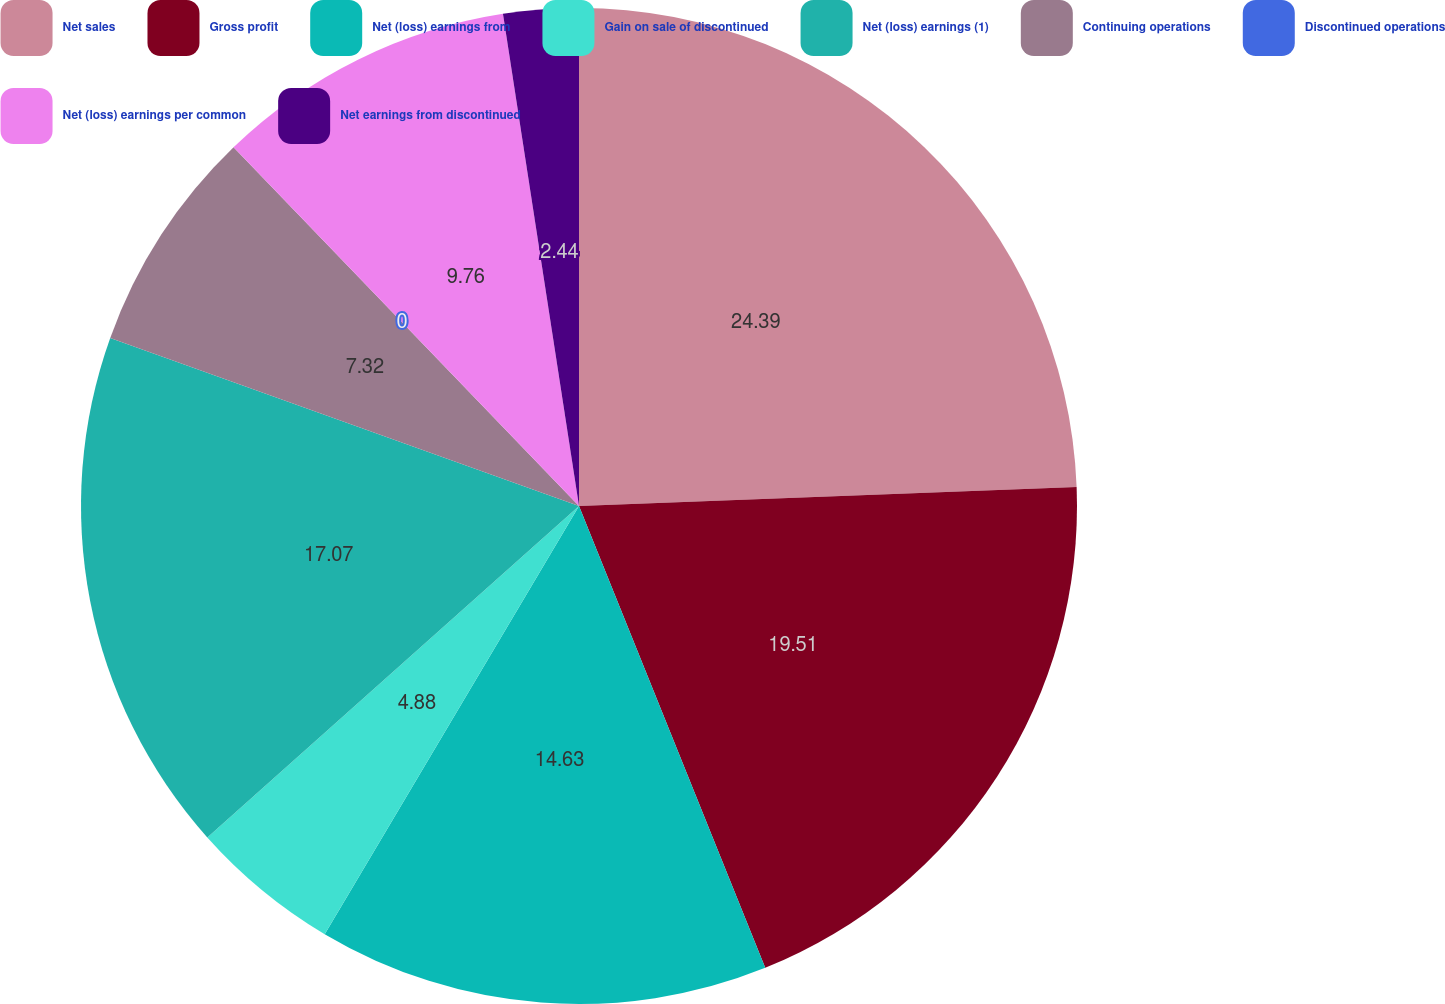Convert chart. <chart><loc_0><loc_0><loc_500><loc_500><pie_chart><fcel>Net sales<fcel>Gross profit<fcel>Net (loss) earnings from<fcel>Gain on sale of discontinued<fcel>Net (loss) earnings (1)<fcel>Continuing operations<fcel>Discontinued operations<fcel>Net (loss) earnings per common<fcel>Net earnings from discontinued<nl><fcel>24.39%<fcel>19.51%<fcel>14.63%<fcel>4.88%<fcel>17.07%<fcel>7.32%<fcel>0.0%<fcel>9.76%<fcel>2.44%<nl></chart> 